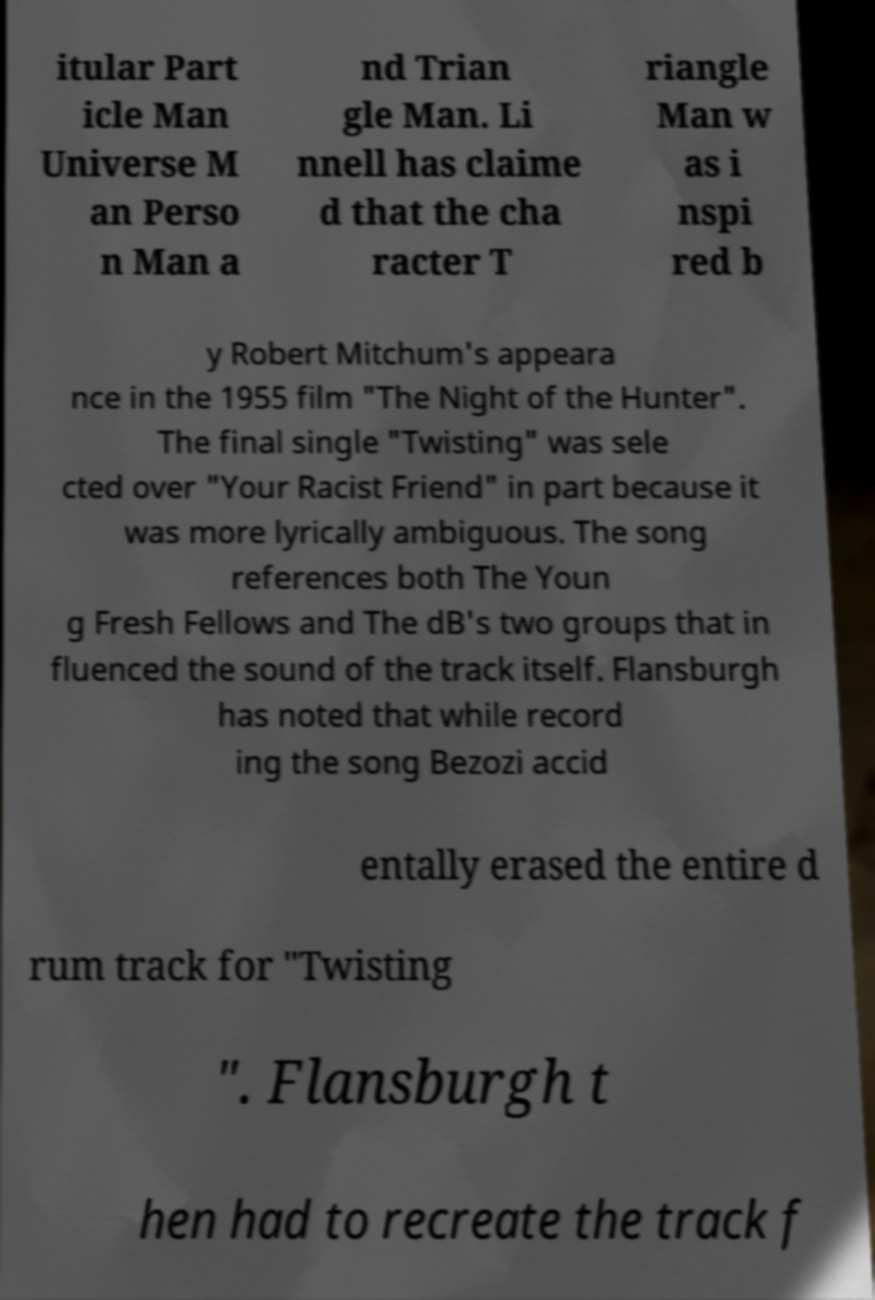Could you extract and type out the text from this image? itular Part icle Man Universe M an Perso n Man a nd Trian gle Man. Li nnell has claime d that the cha racter T riangle Man w as i nspi red b y Robert Mitchum's appeara nce in the 1955 film "The Night of the Hunter". The final single "Twisting" was sele cted over "Your Racist Friend" in part because it was more lyrically ambiguous. The song references both The Youn g Fresh Fellows and The dB's two groups that in fluenced the sound of the track itself. Flansburgh has noted that while record ing the song Bezozi accid entally erased the entire d rum track for "Twisting ". Flansburgh t hen had to recreate the track f 